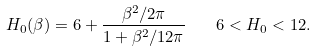Convert formula to latex. <formula><loc_0><loc_0><loc_500><loc_500>H _ { 0 } ( \beta ) = 6 + \frac { \beta ^ { 2 } / 2 \pi } { 1 + \beta ^ { 2 } / 1 2 \pi } \quad 6 < H _ { 0 } < 1 2 .</formula> 